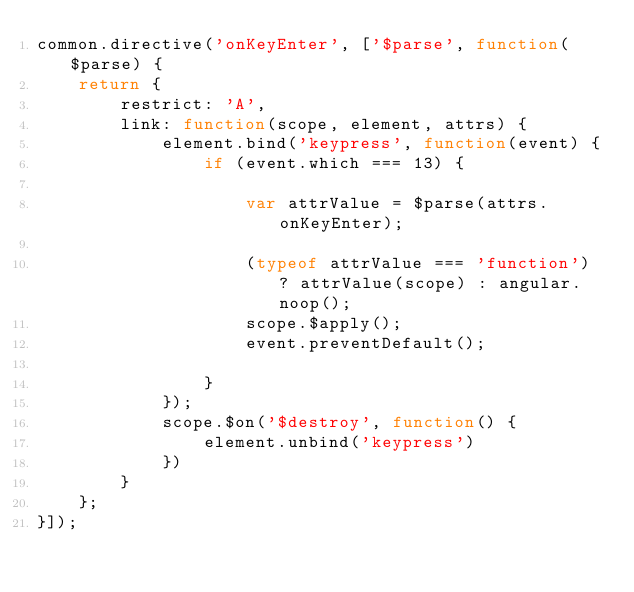Convert code to text. <code><loc_0><loc_0><loc_500><loc_500><_JavaScript_>common.directive('onKeyEnter', ['$parse', function($parse) {
    return {
        restrict: 'A',
        link: function(scope, element, attrs) {
            element.bind('keypress', function(event) {
                if (event.which === 13) {

                    var attrValue = $parse(attrs.onKeyEnter);

                    (typeof attrValue === 'function') ? attrValue(scope) : angular.noop();
                    scope.$apply();
                    event.preventDefault();

                }
            });
            scope.$on('$destroy', function() {
                element.unbind('keypress')
            })
        }
    };
}]);
</code> 